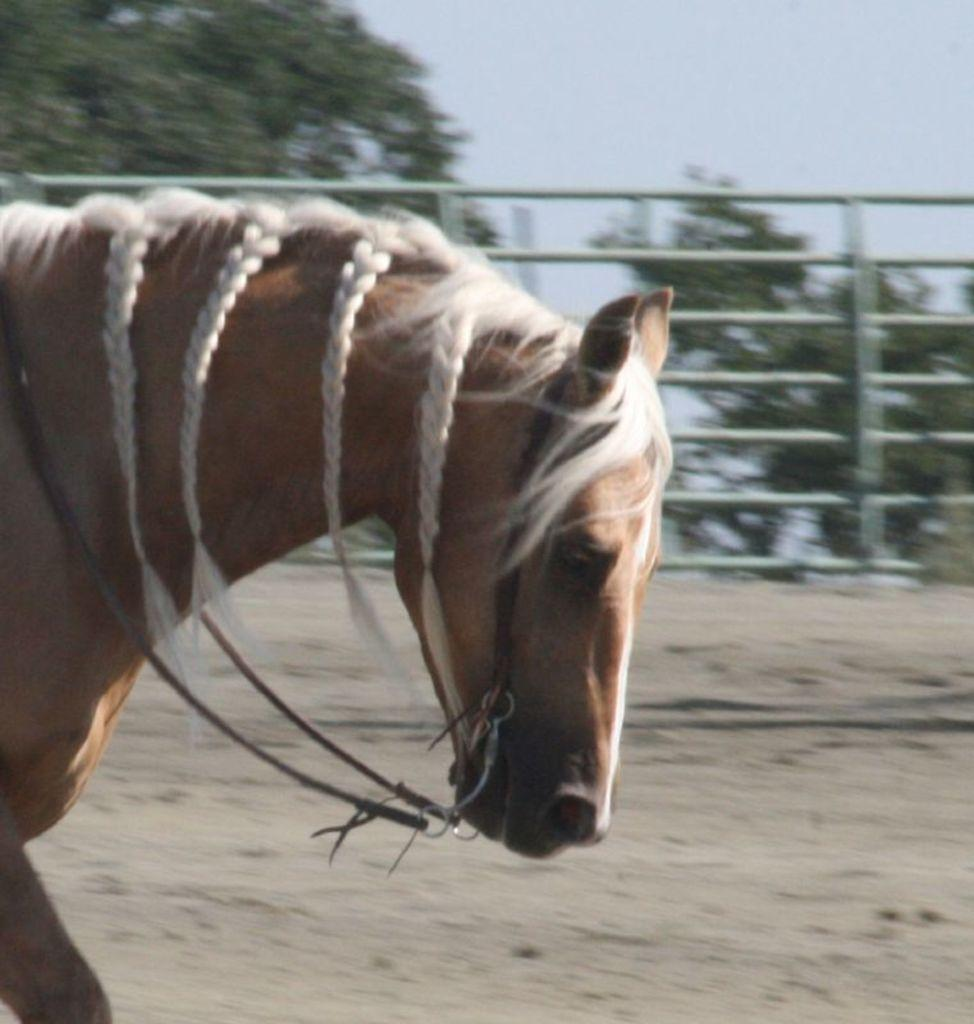What animal is present in the image? There is a horse in the image. What colors can be seen on the horse? The horse is brown and white in color. What is the purpose of the structure in the image? There is a fence in the image, which might be used to contain or separate the horse. What type of natural environment is visible in the image? There are trees in the image, suggesting a natural setting. What is visible in the background of the image? The sky is visible in the image. How many pairs of shoes can be seen hanging from the trees in the image? There are no shoes present in the image; it features a horse, a fence, trees, and the sky. 